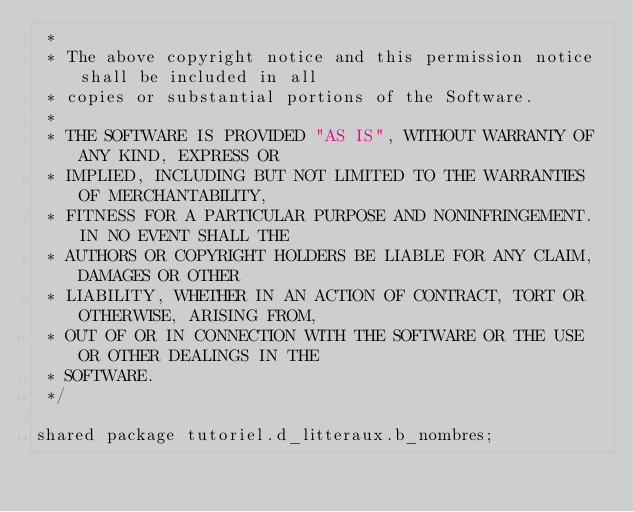Convert code to text. <code><loc_0><loc_0><loc_500><loc_500><_Ceylon_> *
 * The above copyright notice and this permission notice shall be included in all
 * copies or substantial portions of the Software.
 *
 * THE SOFTWARE IS PROVIDED "AS IS", WITHOUT WARRANTY OF ANY KIND, EXPRESS OR
 * IMPLIED, INCLUDING BUT NOT LIMITED TO THE WARRANTIES OF MERCHANTABILITY,
 * FITNESS FOR A PARTICULAR PURPOSE AND NONINFRINGEMENT. IN NO EVENT SHALL THE
 * AUTHORS OR COPYRIGHT HOLDERS BE LIABLE FOR ANY CLAIM, DAMAGES OR OTHER
 * LIABILITY, WHETHER IN AN ACTION OF CONTRACT, TORT OR OTHERWISE, ARISING FROM,
 * OUT OF OR IN CONNECTION WITH THE SOFTWARE OR THE USE OR OTHER DEALINGS IN THE
 * SOFTWARE.
 */

shared package tutoriel.d_litteraux.b_nombres;
</code> 